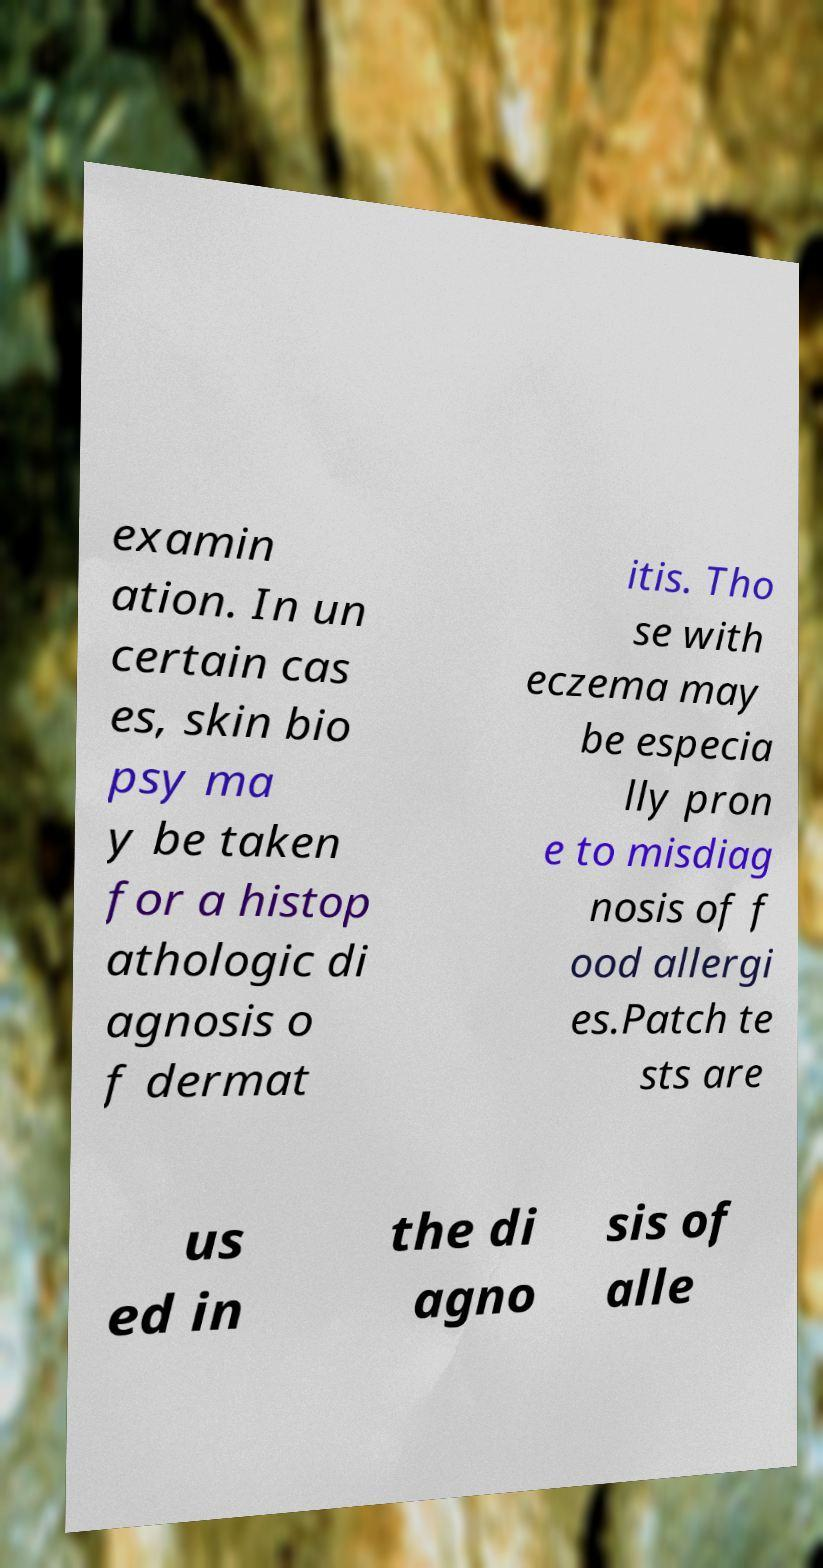I need the written content from this picture converted into text. Can you do that? examin ation. In un certain cas es, skin bio psy ma y be taken for a histop athologic di agnosis o f dermat itis. Tho se with eczema may be especia lly pron e to misdiag nosis of f ood allergi es.Patch te sts are us ed in the di agno sis of alle 